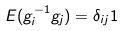Convert formula to latex. <formula><loc_0><loc_0><loc_500><loc_500>E ( g _ { i } ^ { - 1 } g _ { j } ) = \delta _ { i j } 1</formula> 